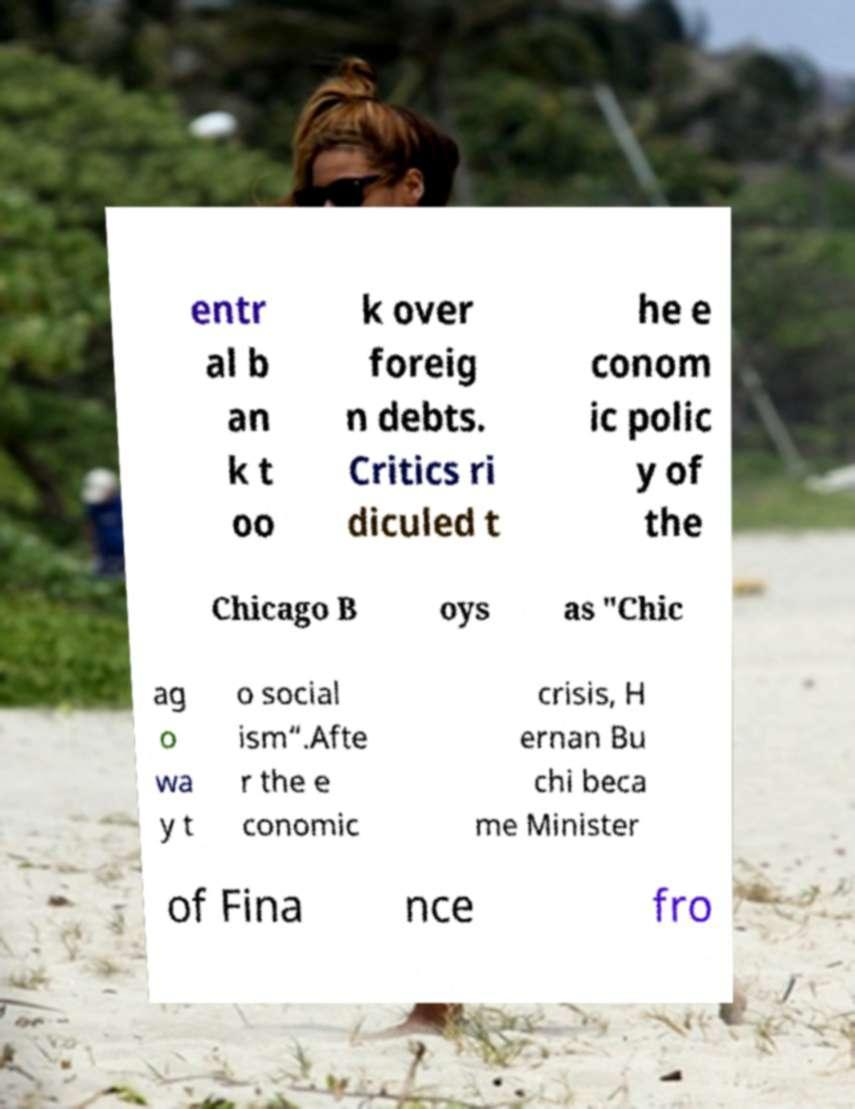Could you extract and type out the text from this image? entr al b an k t oo k over foreig n debts. Critics ri diculed t he e conom ic polic y of the Chicago B oys as "Chic ag o wa y t o social ism“.Afte r the e conomic crisis, H ernan Bu chi beca me Minister of Fina nce fro 